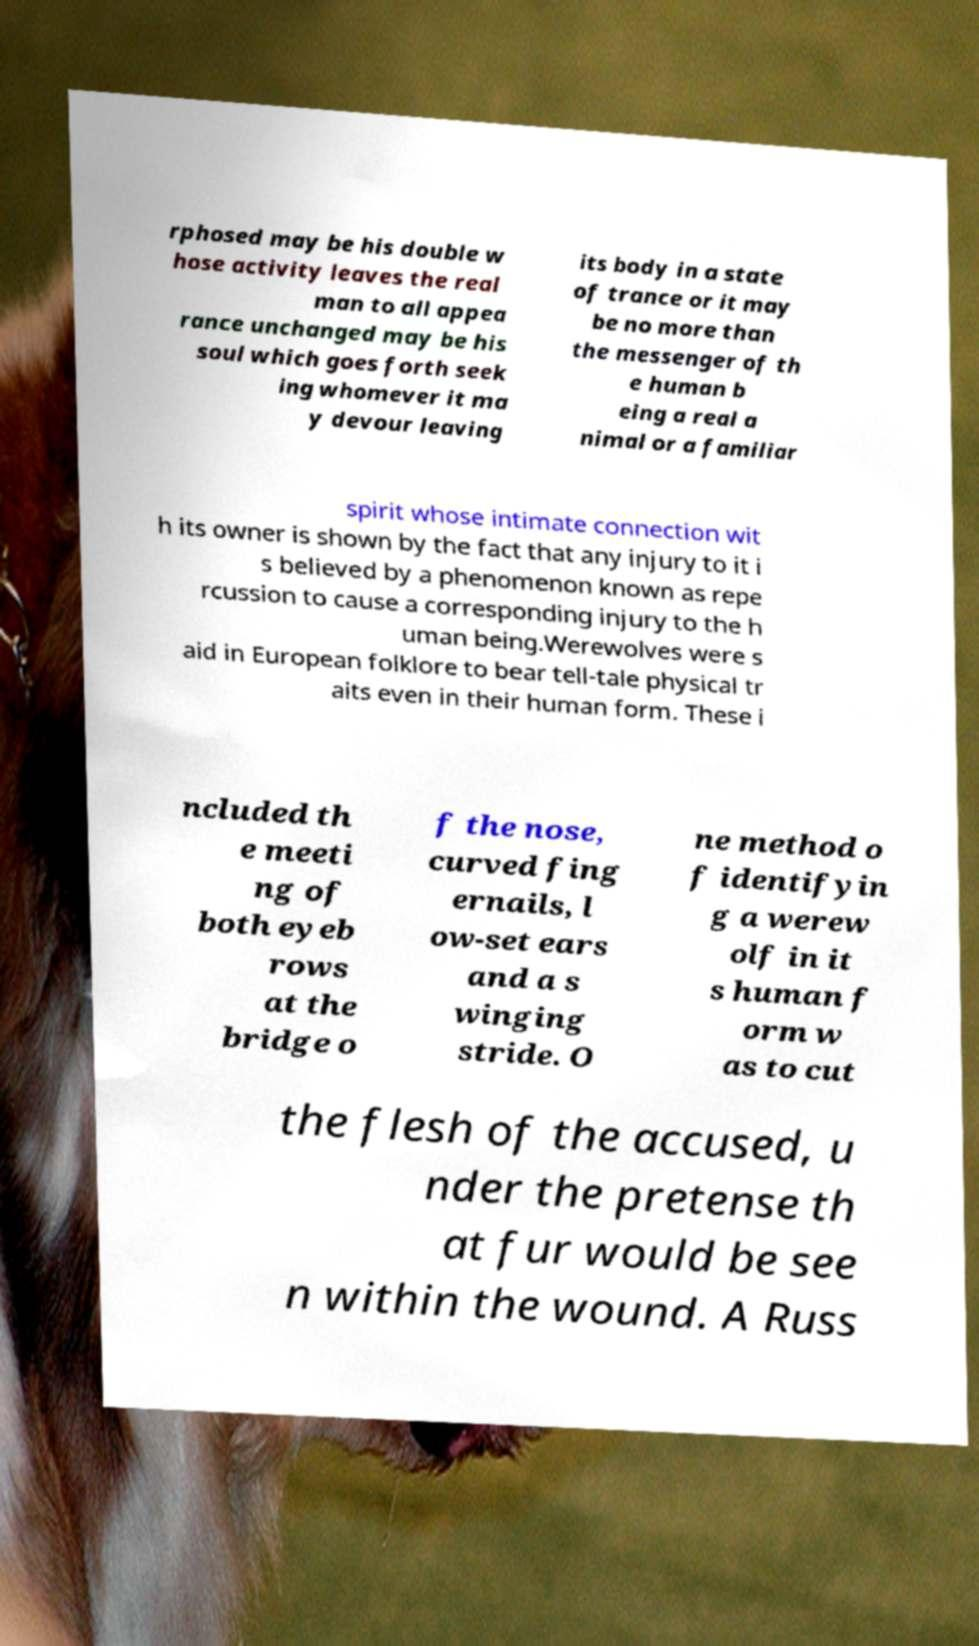Can you accurately transcribe the text from the provided image for me? rphosed may be his double w hose activity leaves the real man to all appea rance unchanged may be his soul which goes forth seek ing whomever it ma y devour leaving its body in a state of trance or it may be no more than the messenger of th e human b eing a real a nimal or a familiar spirit whose intimate connection wit h its owner is shown by the fact that any injury to it i s believed by a phenomenon known as repe rcussion to cause a corresponding injury to the h uman being.Werewolves were s aid in European folklore to bear tell-tale physical tr aits even in their human form. These i ncluded th e meeti ng of both eyeb rows at the bridge o f the nose, curved fing ernails, l ow-set ears and a s winging stride. O ne method o f identifyin g a werew olf in it s human f orm w as to cut the flesh of the accused, u nder the pretense th at fur would be see n within the wound. A Russ 